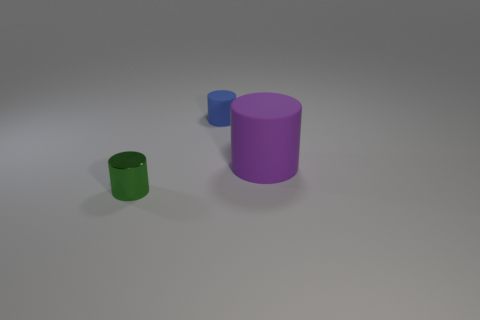Are there any other things that have the same material as the small green thing?
Make the answer very short. No. Is the number of big blue rubber balls greater than the number of big matte things?
Keep it short and to the point. No. What color is the other rubber thing that is the same shape as the big purple thing?
Your response must be concise. Blue. What material is the cylinder that is both to the left of the big thing and in front of the blue cylinder?
Your answer should be very brief. Metal. Do the cylinder on the right side of the tiny rubber thing and the small object that is in front of the tiny blue object have the same material?
Offer a terse response. No. How big is the blue cylinder?
Keep it short and to the point. Small. The green metal object that is the same shape as the purple thing is what size?
Offer a very short reply. Small. What number of tiny blue rubber cylinders are on the right side of the big cylinder?
Your response must be concise. 0. What is the color of the rubber object that is right of the matte cylinder on the left side of the big thing?
Your answer should be compact. Purple. Are there the same number of large matte objects that are behind the big rubber thing and purple cylinders on the left side of the metallic thing?
Provide a short and direct response. Yes. 